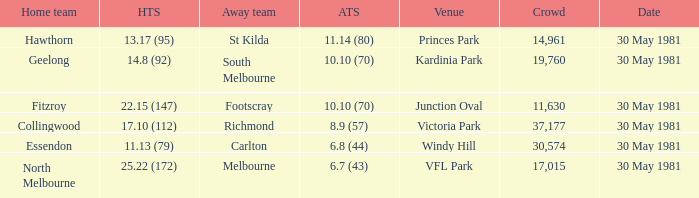What did carlton score while away? 6.8 (44). 